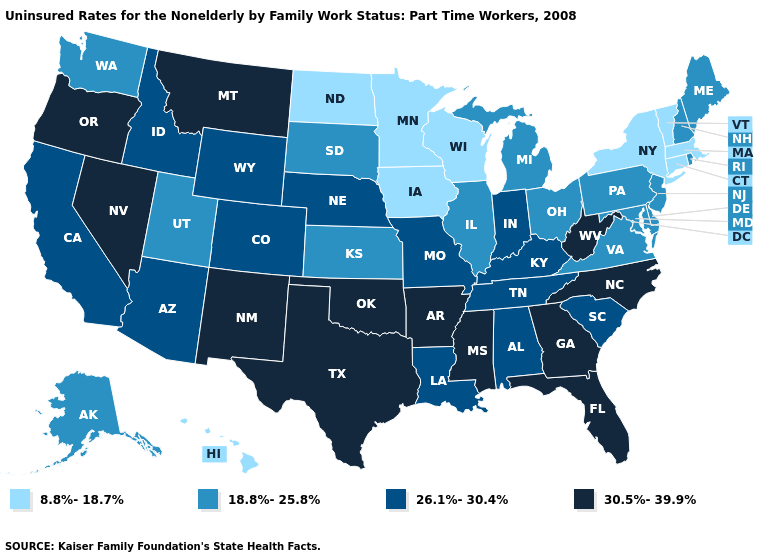Does the map have missing data?
Keep it brief. No. Among the states that border Oklahoma , does Arkansas have the highest value?
Answer briefly. Yes. What is the value of Vermont?
Write a very short answer. 8.8%-18.7%. What is the value of Nevada?
Give a very brief answer. 30.5%-39.9%. Name the states that have a value in the range 18.8%-25.8%?
Give a very brief answer. Alaska, Delaware, Illinois, Kansas, Maine, Maryland, Michigan, New Hampshire, New Jersey, Ohio, Pennsylvania, Rhode Island, South Dakota, Utah, Virginia, Washington. What is the highest value in the South ?
Answer briefly. 30.5%-39.9%. What is the value of Maine?
Be succinct. 18.8%-25.8%. Which states have the highest value in the USA?
Short answer required. Arkansas, Florida, Georgia, Mississippi, Montana, Nevada, New Mexico, North Carolina, Oklahoma, Oregon, Texas, West Virginia. Does New Jersey have a lower value than Delaware?
Write a very short answer. No. Is the legend a continuous bar?
Keep it brief. No. Which states hav the highest value in the South?
Concise answer only. Arkansas, Florida, Georgia, Mississippi, North Carolina, Oklahoma, Texas, West Virginia. What is the value of Tennessee?
Give a very brief answer. 26.1%-30.4%. Does the map have missing data?
Be succinct. No. Among the states that border New Hampshire , which have the lowest value?
Short answer required. Massachusetts, Vermont. Name the states that have a value in the range 8.8%-18.7%?
Write a very short answer. Connecticut, Hawaii, Iowa, Massachusetts, Minnesota, New York, North Dakota, Vermont, Wisconsin. 